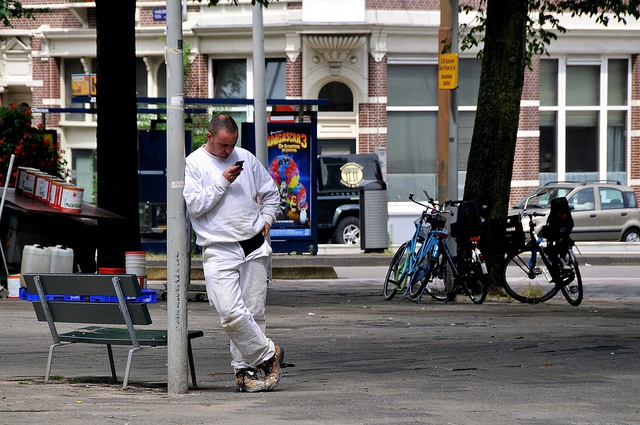Describe the objects in this image and their specific colors. I can see people in black, lavender, darkgray, and gray tones, bench in black, gray, darkgray, and purple tones, bicycle in black, gray, darkgray, and lightgray tones, car in black, gray, darkgray, and lightgray tones, and car in black, gray, and darkgray tones in this image. 